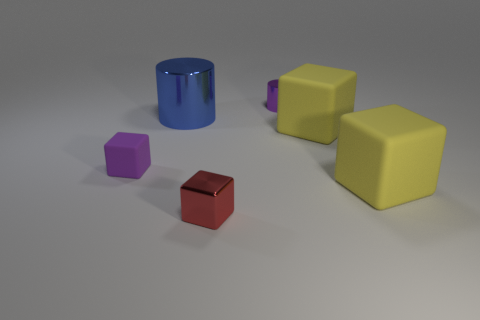Subtract all small metallic cubes. How many cubes are left? 3 Add 3 small red cubes. How many objects exist? 9 Subtract all red spheres. How many yellow blocks are left? 2 Subtract all purple cylinders. How many cylinders are left? 1 Subtract all cubes. How many objects are left? 2 Subtract all green cubes. Subtract all red spheres. How many cubes are left? 4 Add 5 big blue shiny cylinders. How many big blue shiny cylinders exist? 6 Subtract 1 blue cylinders. How many objects are left? 5 Subtract all large cubes. Subtract all big cubes. How many objects are left? 2 Add 1 purple metal cylinders. How many purple metal cylinders are left? 2 